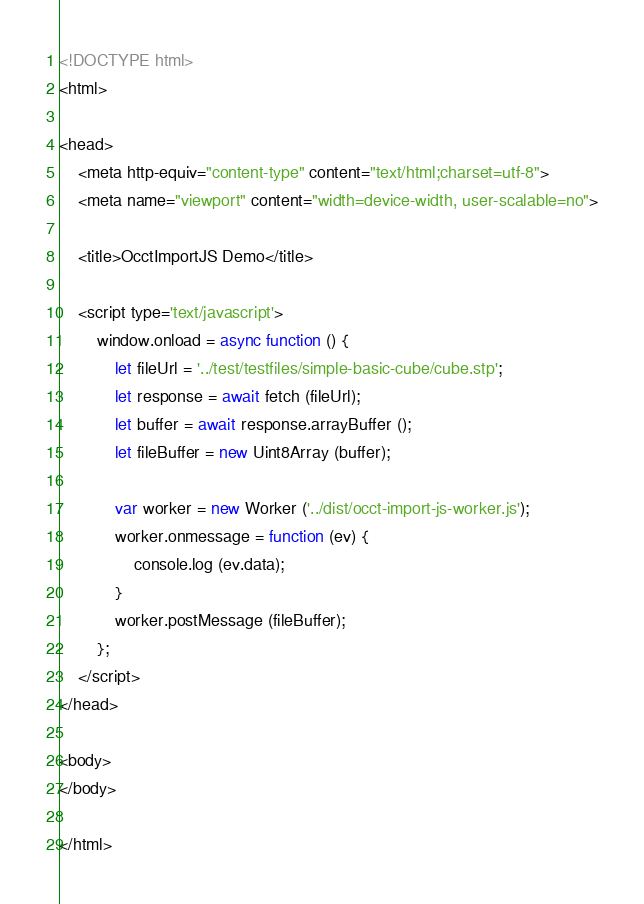Convert code to text. <code><loc_0><loc_0><loc_500><loc_500><_HTML_><!DOCTYPE html>
<html>

<head>
    <meta http-equiv="content-type" content="text/html;charset=utf-8">
    <meta name="viewport" content="width=device-width, user-scalable=no">

    <title>OcctImportJS Demo</title>
    
    <script type='text/javascript'>
        window.onload = async function () {
            let fileUrl = '../test/testfiles/simple-basic-cube/cube.stp';
            let response = await fetch (fileUrl);
            let buffer = await response.arrayBuffer ();
            let fileBuffer = new Uint8Array (buffer);

            var worker = new Worker ('../dist/occt-import-js-worker.js');
            worker.onmessage = function (ev) {
                console.log (ev.data);
            }
            worker.postMessage (fileBuffer);
        };
    </script>
</head>

<body>
</body>

</html>
</code> 